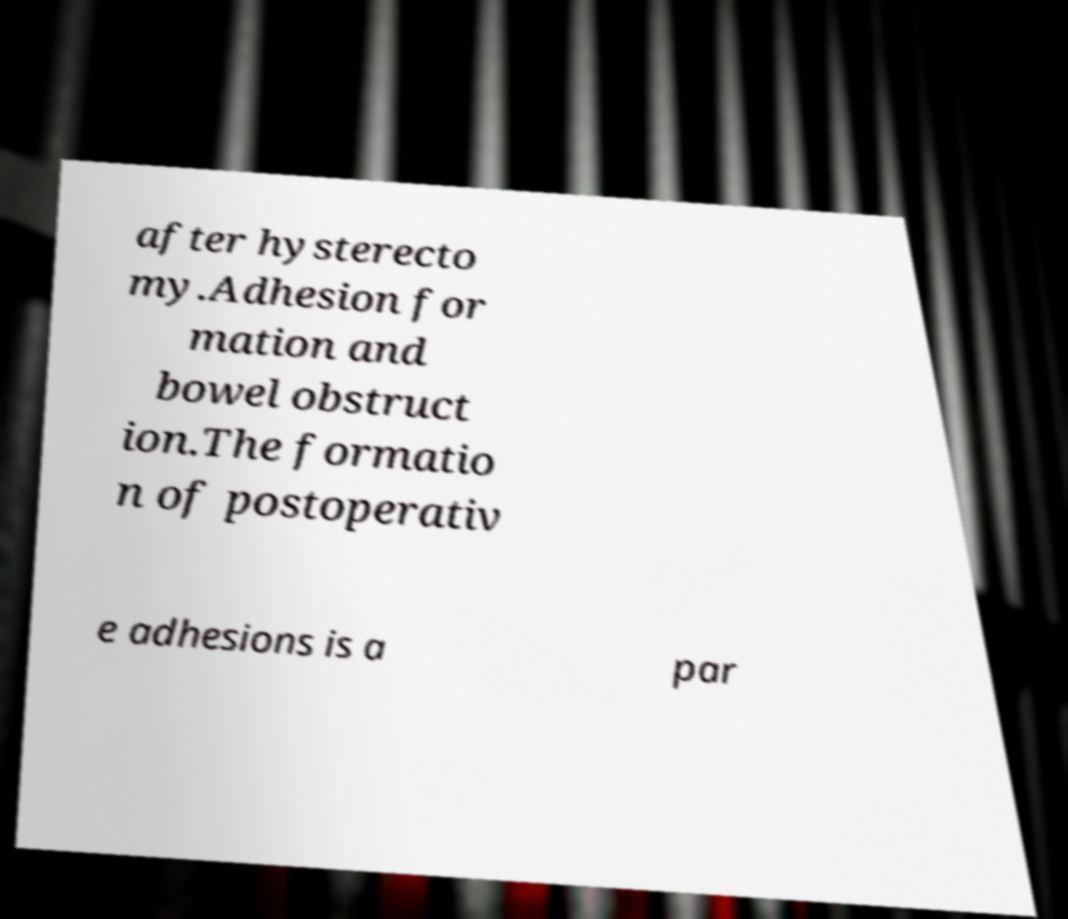Please read and relay the text visible in this image. What does it say? after hysterecto my.Adhesion for mation and bowel obstruct ion.The formatio n of postoperativ e adhesions is a par 